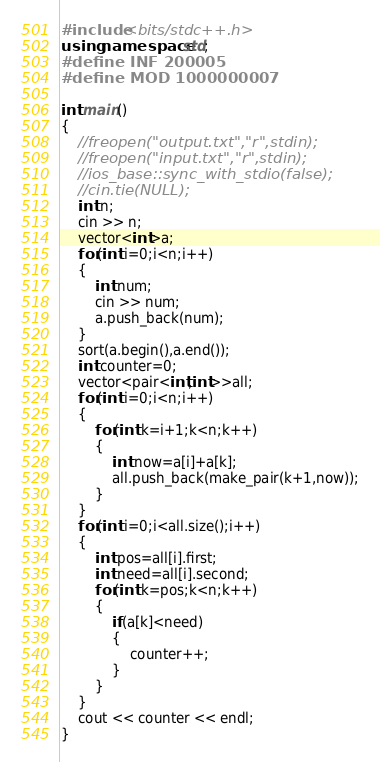Convert code to text. <code><loc_0><loc_0><loc_500><loc_500><_C++_>#include <bits/stdc++.h>
using namespace std;
#define INF 200005
#define MOD 1000000007

int main()
{
    //freopen("output.txt","r",stdin);
    //freopen("input.txt","r",stdin);
    //ios_base::sync_with_stdio(false);
    //cin.tie(NULL);
    int n;
    cin >> n;
    vector<int>a;
    for(int i=0;i<n;i++)
    {
        int num;
        cin >> num;
        a.push_back(num);
    }
    sort(a.begin(),a.end());
    int counter=0;
    vector<pair<int,int>>all;
    for(int i=0;i<n;i++)
    {
        for(int k=i+1;k<n;k++)
        {
            int now=a[i]+a[k];
            all.push_back(make_pair(k+1,now));
        }
    }
    for(int i=0;i<all.size();i++)
    {
        int pos=all[i].first;
        int need=all[i].second;
        for(int k=pos;k<n;k++)
        {
            if(a[k]<need)
            {
                counter++;
            }
        }
    }
    cout << counter << endl;
}
</code> 